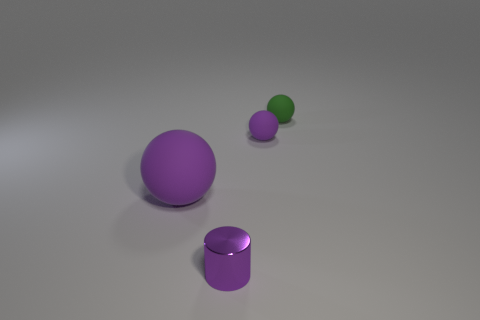Add 4 big blue matte balls. How many objects exist? 8 Subtract all spheres. How many objects are left? 1 Add 4 purple matte things. How many purple matte things exist? 6 Subtract 0 cyan cylinders. How many objects are left? 4 Subtract all big objects. Subtract all small green balls. How many objects are left? 2 Add 3 rubber spheres. How many rubber spheres are left? 6 